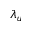<formula> <loc_0><loc_0><loc_500><loc_500>\lambda _ { u }</formula> 